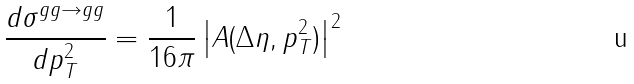Convert formula to latex. <formula><loc_0><loc_0><loc_500><loc_500>\frac { d \sigma ^ { g g \rightarrow g g } } { d p _ { T } ^ { 2 } } = \frac { 1 } { 1 6 \pi } \left | A ( \Delta \eta , p _ { T } ^ { 2 } ) \right | ^ { 2 }</formula> 